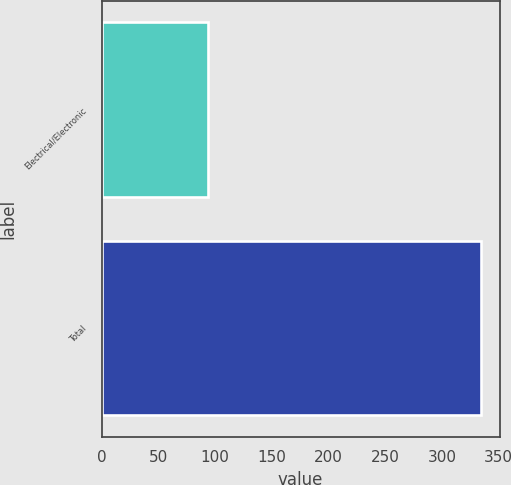Convert chart to OTSL. <chart><loc_0><loc_0><loc_500><loc_500><bar_chart><fcel>Electrical/Electronic<fcel>Total<nl><fcel>94<fcel>334<nl></chart> 